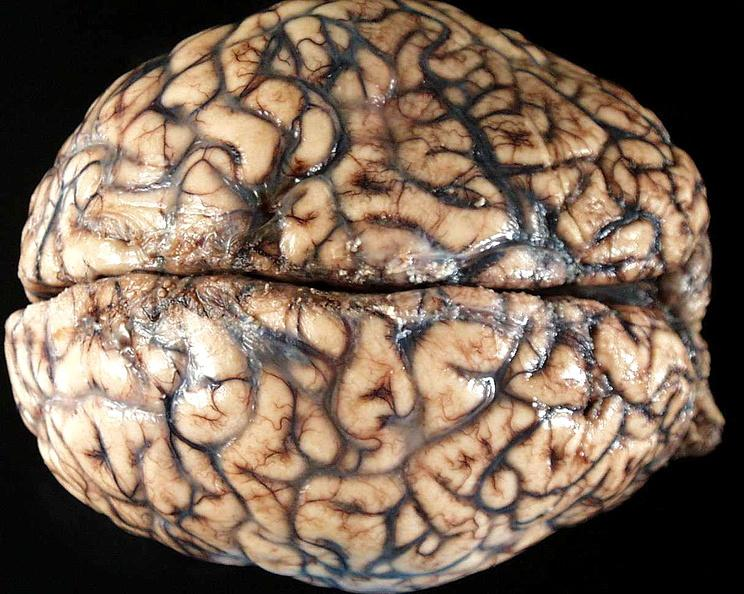s nervous present?
Answer the question using a single word or phrase. Yes 